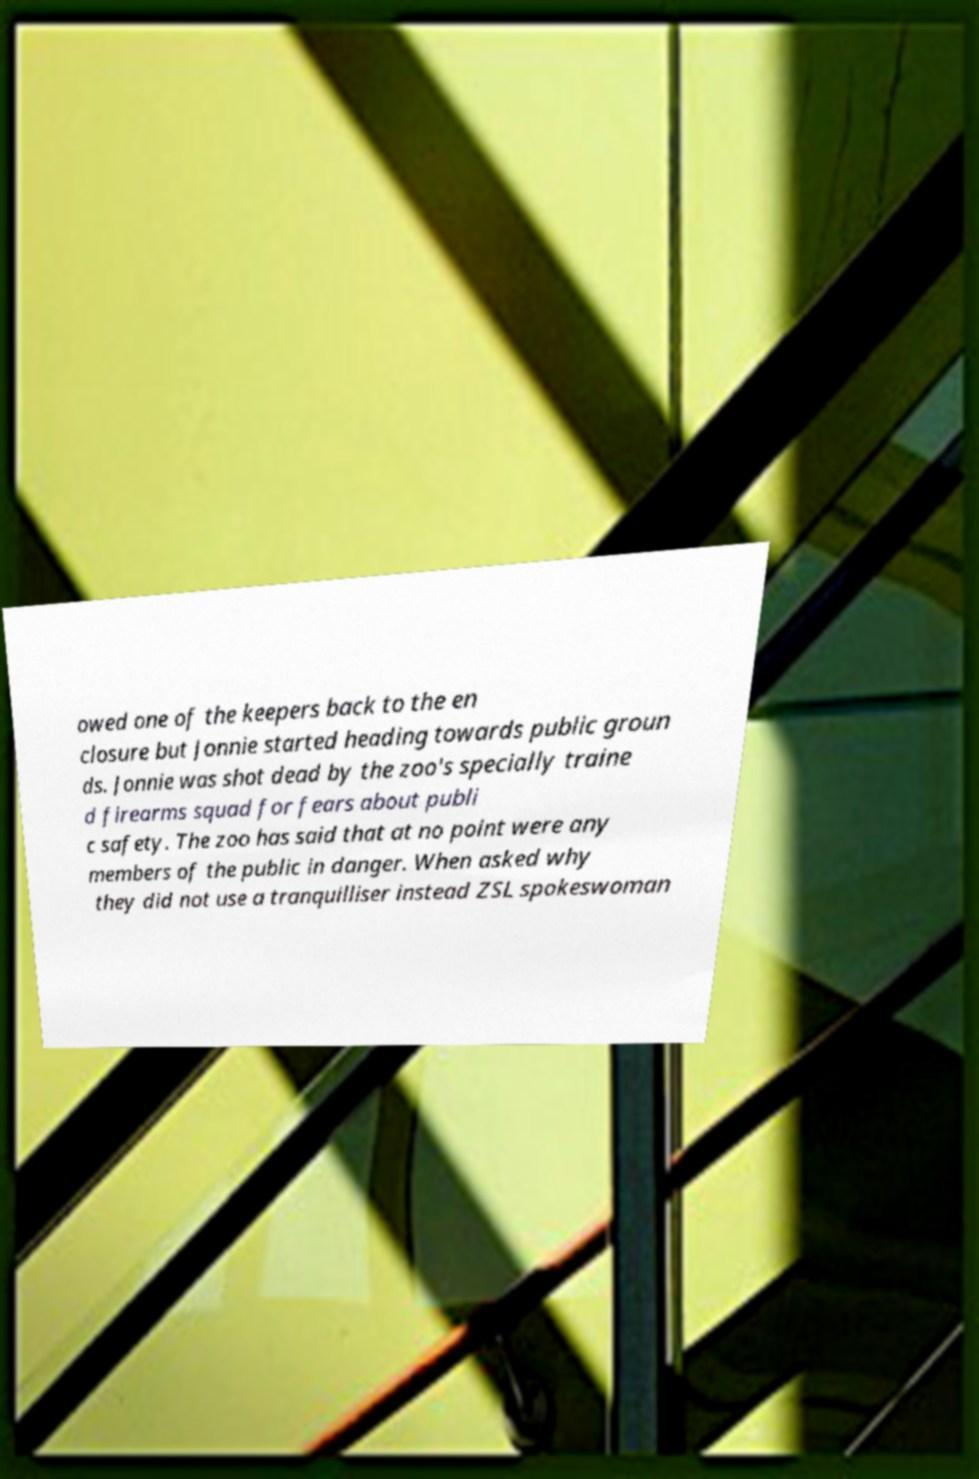Please identify and transcribe the text found in this image. owed one of the keepers back to the en closure but Jonnie started heading towards public groun ds. Jonnie was shot dead by the zoo's specially traine d firearms squad for fears about publi c safety. The zoo has said that at no point were any members of the public in danger. When asked why they did not use a tranquilliser instead ZSL spokeswoman 